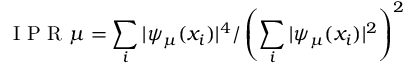Convert formula to latex. <formula><loc_0><loc_0><loc_500><loc_500>I P R \mu = \sum _ { i } | \psi _ { \mu } ( x _ { i } ) | ^ { 4 } / \left ( \sum _ { i } | \psi _ { \mu } ( x _ { i } ) | ^ { 2 } \right ) ^ { 2 }</formula> 